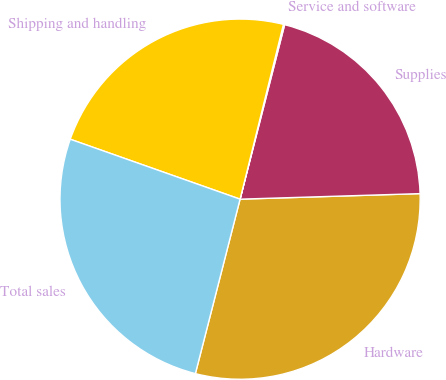Convert chart to OTSL. <chart><loc_0><loc_0><loc_500><loc_500><pie_chart><fcel>Hardware<fcel>Supplies<fcel>Service and software<fcel>Shipping and handling<fcel>Total sales<nl><fcel>29.48%<fcel>20.53%<fcel>0.11%<fcel>23.47%<fcel>26.41%<nl></chart> 